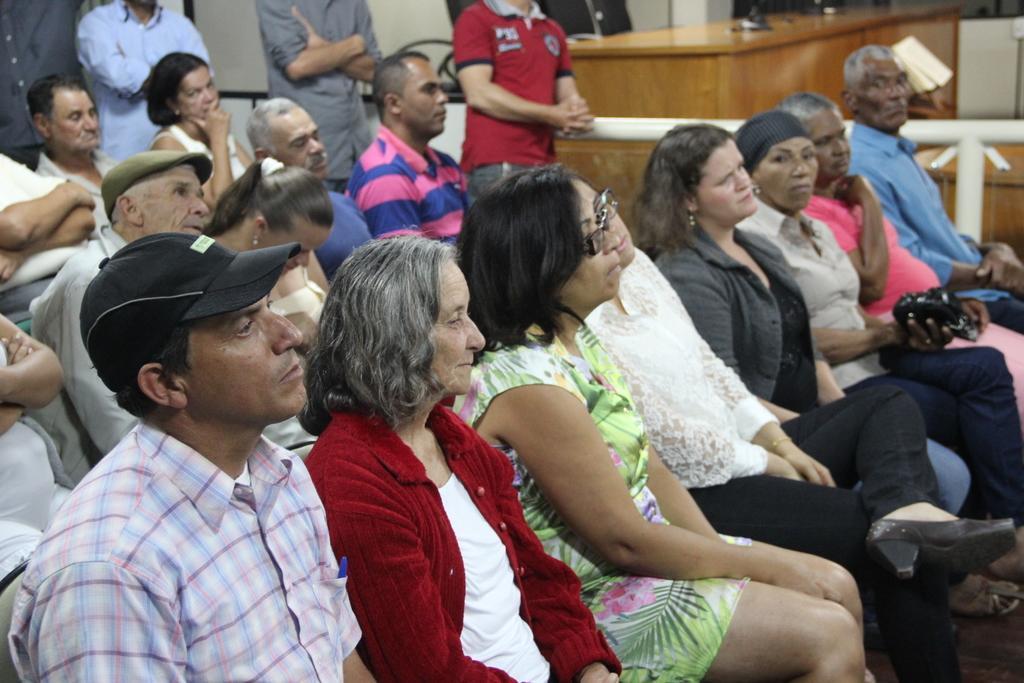Can you describe this image briefly? In this image we can see people sitting and four persons are standing in the background. Image also consists of empty chairs and also a wooden table. 